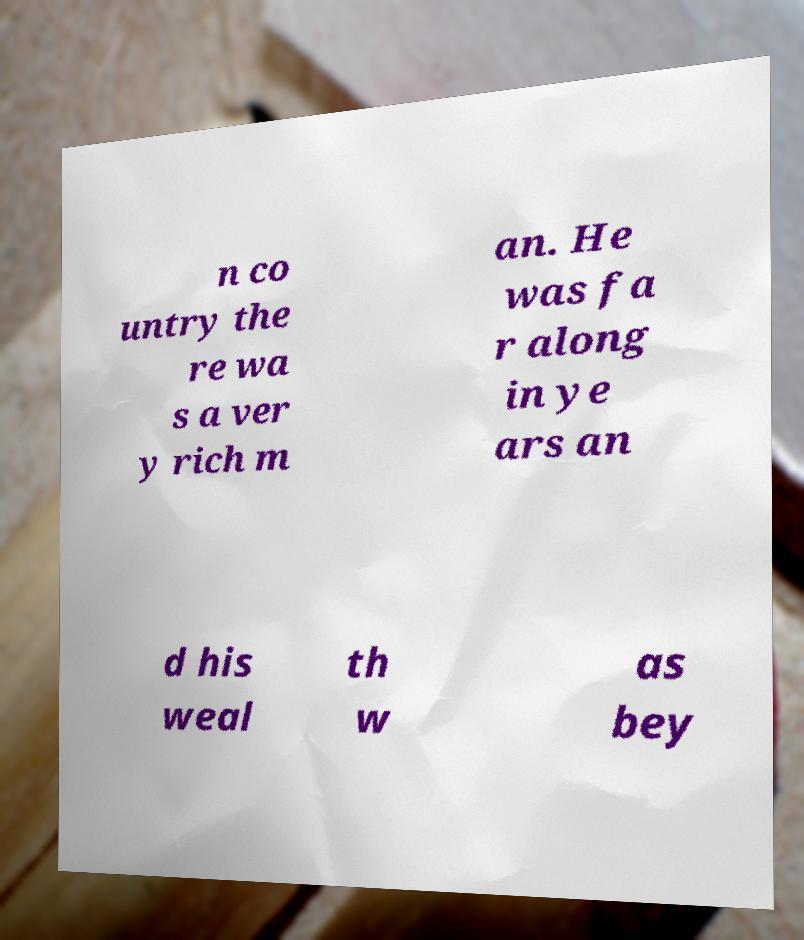What messages or text are displayed in this image? I need them in a readable, typed format. n co untry the re wa s a ver y rich m an. He was fa r along in ye ars an d his weal th w as bey 